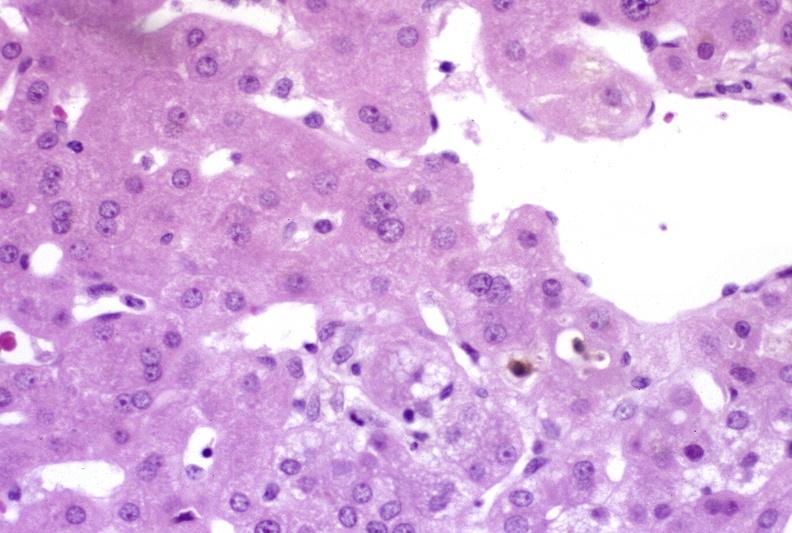what is present?
Answer the question using a single word or phrase. Hepatobiliary 